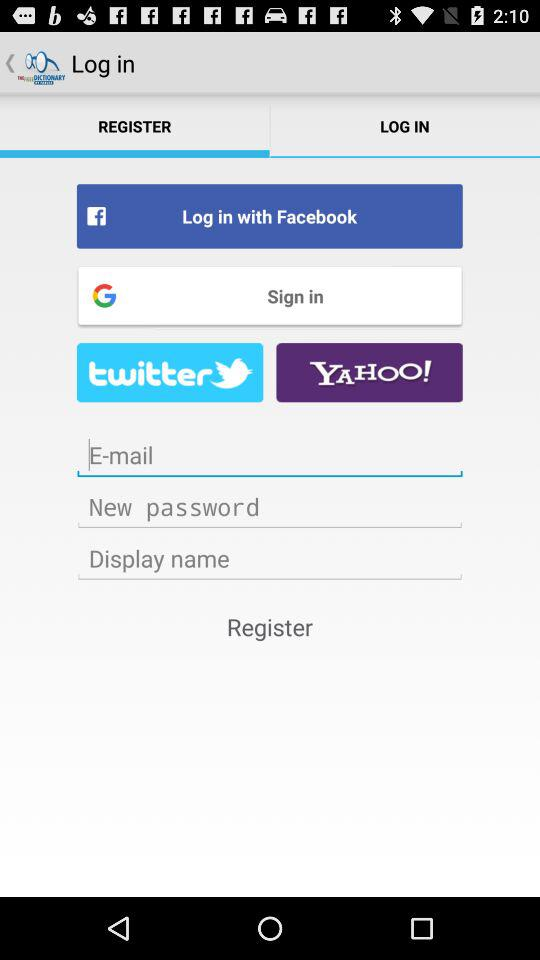What accounts can be used to sign in? The accounts are "Facebook", "Google", "twitter", "YAHOO!" and "E-mail". 